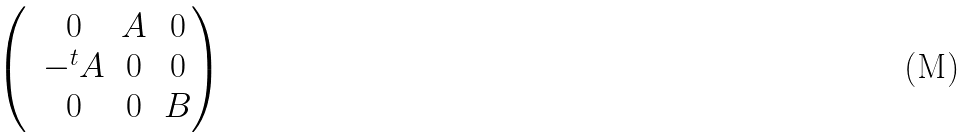Convert formula to latex. <formula><loc_0><loc_0><loc_500><loc_500>\begin{pmatrix} & 0 & A & 0 \\ & - { ^ { t } A } & 0 & 0 \\ & 0 & 0 & B \end{pmatrix}</formula> 